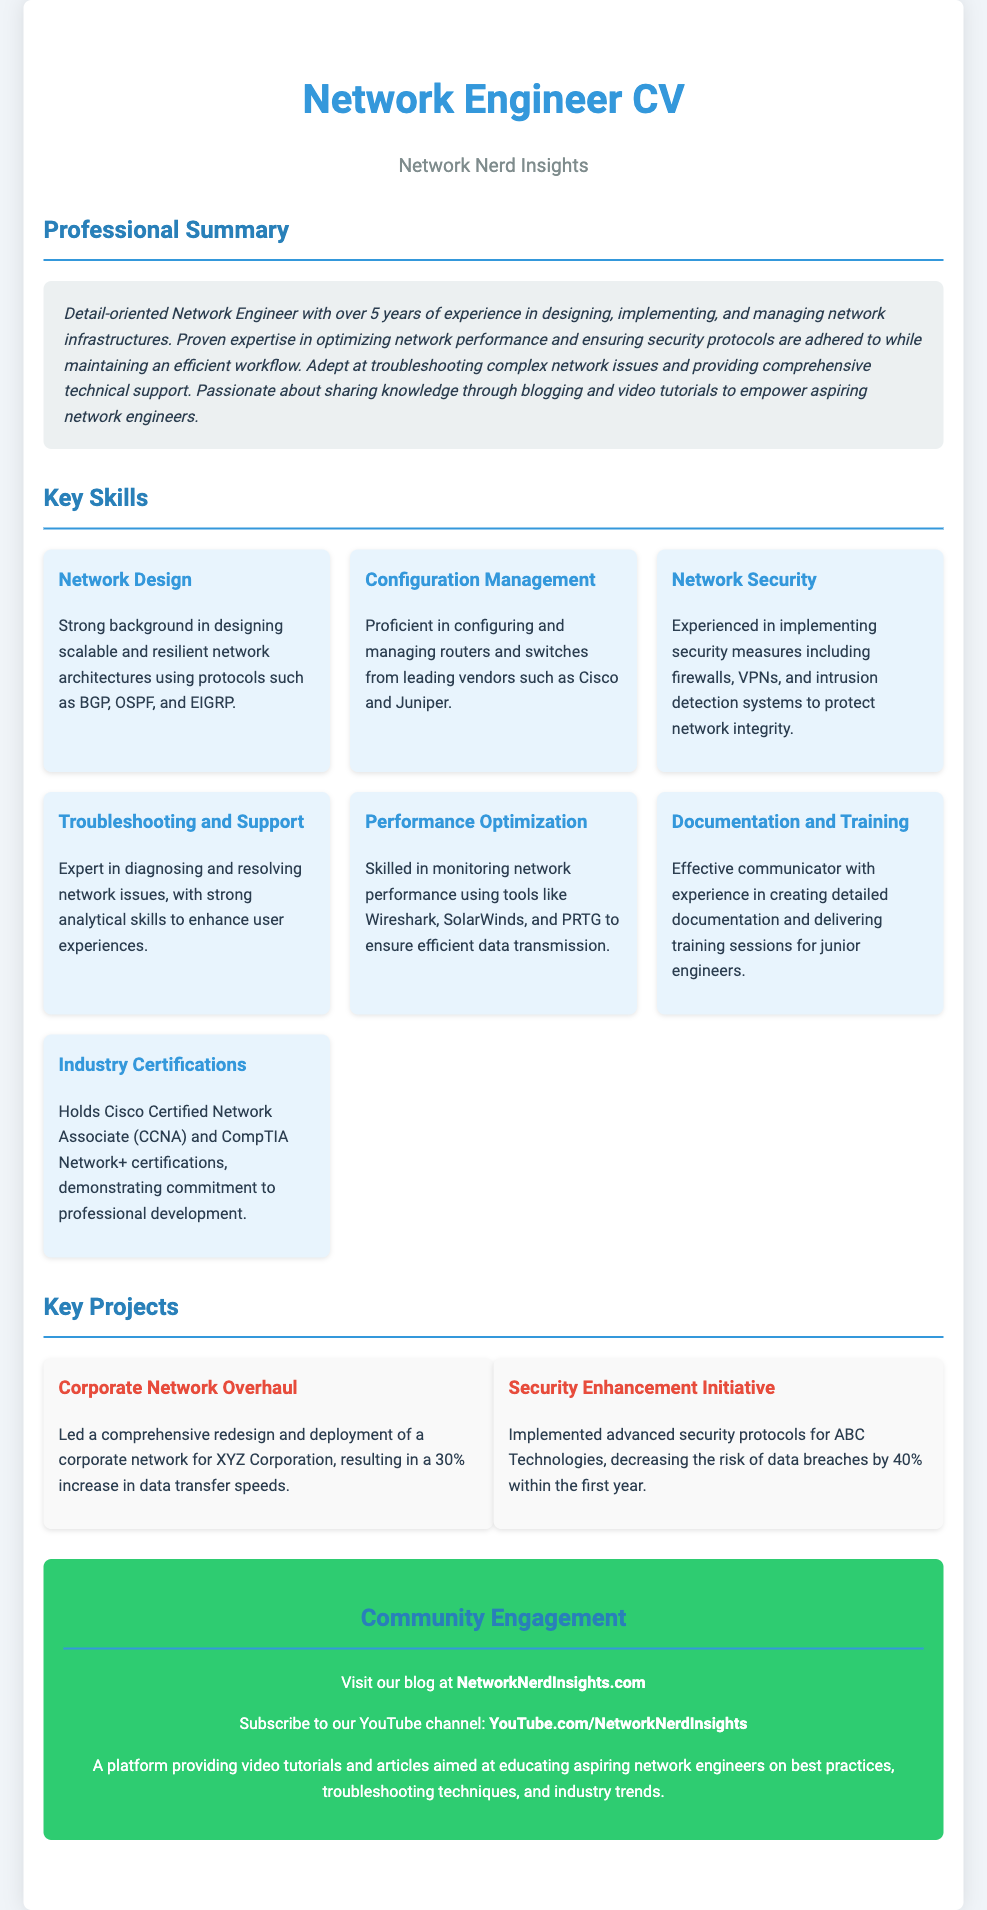What is the number of years of experience mentioned? The document states that the network engineer has over 5 years of experience in the professional summary.
Answer: 5 years What title is given to the document? The title of the document is stated prominently at the top, reading "Network Engineer CV".
Answer: Network Engineer CV Which key skill focuses on security? The key skills include one specifically labeled as "Network Security", which pertains to security measures.
Answer: Network Security What is the name of the website provided for community engagement? The document provides the URL "NetworkNerdInsights.com" as the blog for community engagement.
Answer: NetworkNerdInsights.com Which certification is mentioned as held by the individual? One of the industry certifications mentioned is "Cisco Certified Network Associate (CCNA)".
Answer: Cisco Certified Network Associate (CCNA) What is the outcome of the "Corporate Network Overhaul" project? The document states that the project led to a "30% increase in data transfer speeds".
Answer: 30% increase in data transfer speeds What tool is mentioned for monitoring network performance? The document lists several tools, one of which is "Wireshark", used for monitoring network performance.
Answer: Wireshark What is the color scheme used in the document headers? The headers in the document primarily use two colors: a blueish color (#3498db) and a light border color (#2980b9).
Answer: Blueish color (#3498db) and light border color (#2980b9) 